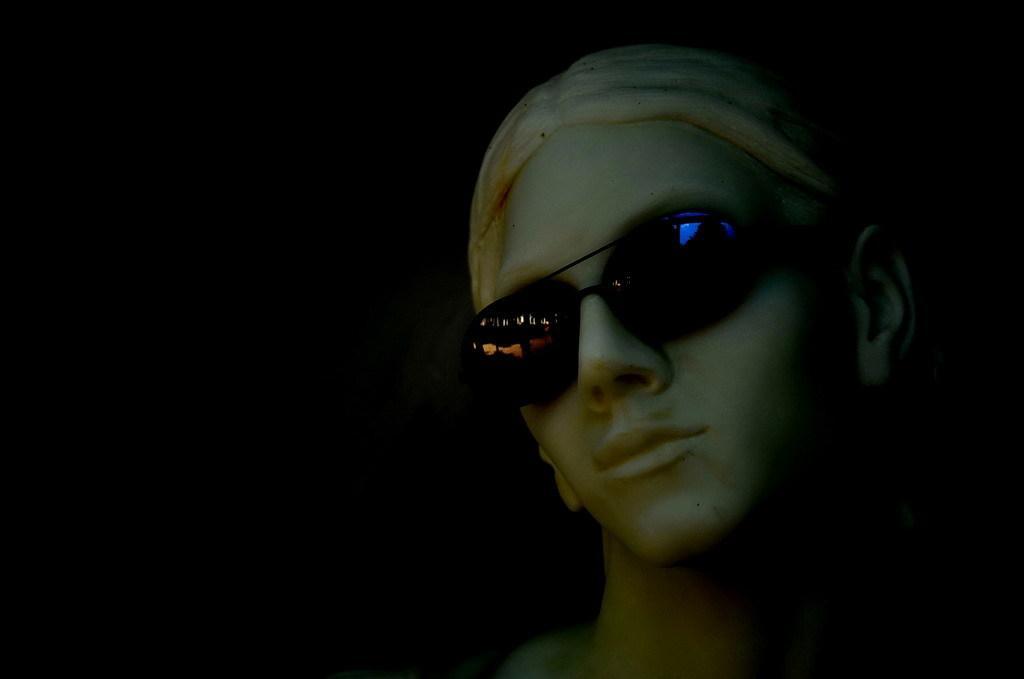Describe this image in one or two sentences. In this image I can see a person wearing a spectacle and in the background I can see dark view 